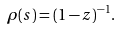<formula> <loc_0><loc_0><loc_500><loc_500>\rho ( s ) = ( 1 - z ) ^ { - 1 } .</formula> 